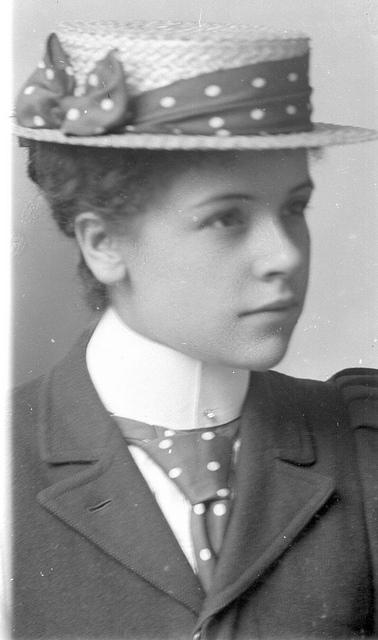Is she wearing a bonnet?
Give a very brief answer. Yes. Was the woman's collar treated with starch?
Give a very brief answer. Yes. What pattern does the woman have on?
Be succinct. Polka dot. 